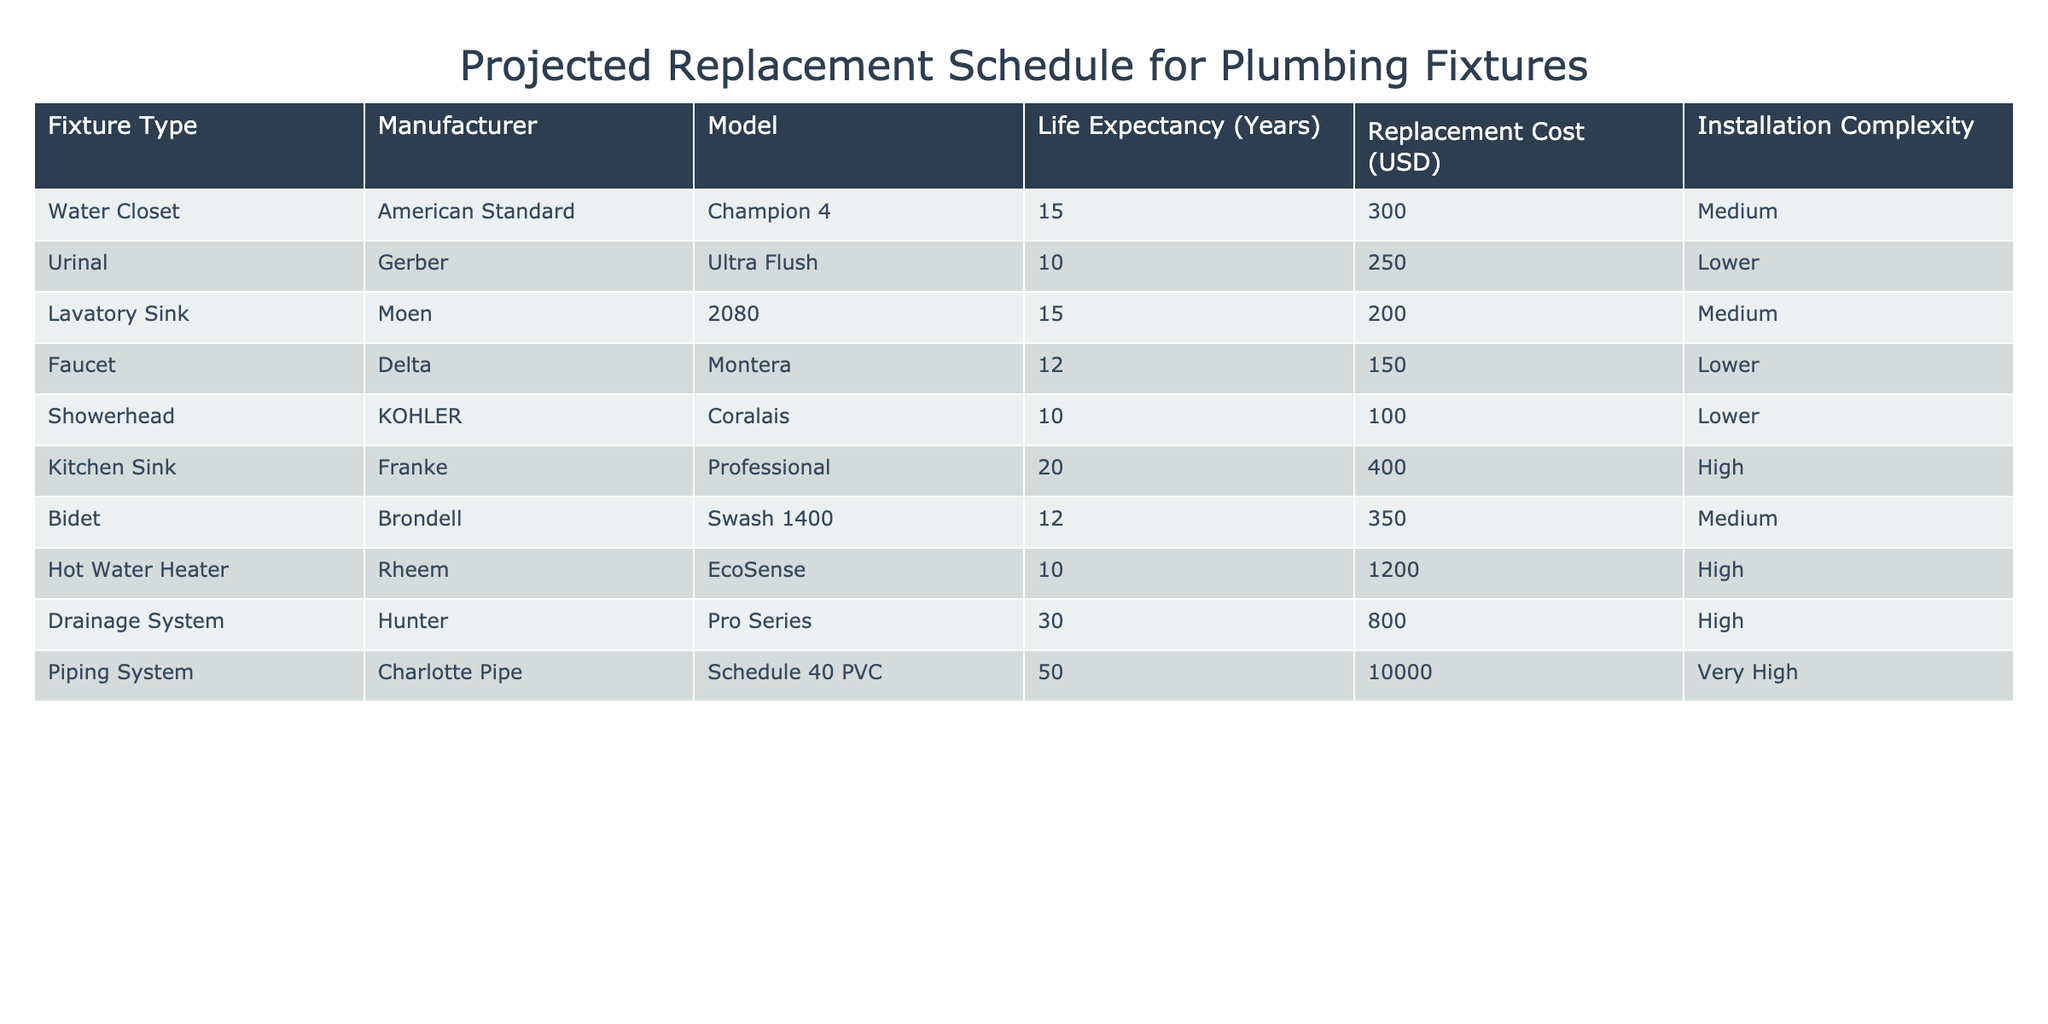What is the life expectancy of a Water Closet? The table shows that the life expectancy of a Water Closet is listed as 15 years.
Answer: 15 years Which plumbing fixture has the highest replacement cost? By examining the "Replacement Cost (USD)" column, the highest cost is for the Piping System at 10,000 USD.
Answer: 10,000 USD How much does it cost to replace a Hot Water Heater? The table specifies that the Replacement Cost for a Hot Water Heater is 1,200 USD.
Answer: 1,200 USD What is the average life expectancy of the plumbing fixtures listed? To find the average, sum the life expectancies: 15 + 10 + 15 + 12 + 10 + 20 + 12 + 10 + 30 + 50 =  200. There are 10 fixtures, so the average is 200/10 = 20 years.
Answer: 20 years Is the installation complexity of a Kitchen Sink considered high? The table indicates that the installation complexity for a Kitchen Sink is classified as "High."
Answer: Yes Which fixture types have a life expectancy greater than 15 years? Reviewing the life expectancy values, the fixtures with greater than 15 years are: Kitchen Sink (20 years) and Piping System (50 years).
Answer: Kitchen Sink, Piping System What is the total replacement cost for fixtures with a life expectancy of 10 years? The fixtures with a life expectancy of 10 years are the Urinal, Showerhead, and Hot Water Heater. Their replacement costs are: 250 + 100 + 1,200 = 1,550 USD.
Answer: 1,550 USD Does a Lavatory Sink have a longer life expectancy than a Bidet? Checking the life expectancy values, both the Lavatory Sink and Bidet have 15 and 12 years, respectively. Thus, the Lavatory Sink has a longer life expectancy.
Answer: Yes How many fixtures have a medium installation complexity? The table indicates that there are four fixtures with a medium installation complexity: Water Closet, Lavatory Sink, Bidet, and Kitchen Sink.
Answer: 4 